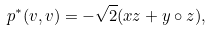Convert formula to latex. <formula><loc_0><loc_0><loc_500><loc_500>p ^ { * } ( v , v ) = - \sqrt { 2 } ( x z + y \circ z ) ,</formula> 